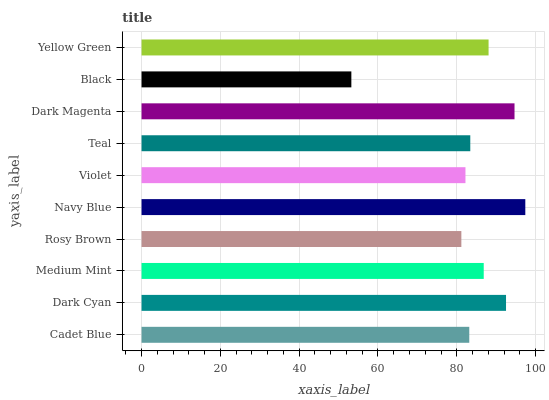Is Black the minimum?
Answer yes or no. Yes. Is Navy Blue the maximum?
Answer yes or no. Yes. Is Dark Cyan the minimum?
Answer yes or no. No. Is Dark Cyan the maximum?
Answer yes or no. No. Is Dark Cyan greater than Cadet Blue?
Answer yes or no. Yes. Is Cadet Blue less than Dark Cyan?
Answer yes or no. Yes. Is Cadet Blue greater than Dark Cyan?
Answer yes or no. No. Is Dark Cyan less than Cadet Blue?
Answer yes or no. No. Is Medium Mint the high median?
Answer yes or no. Yes. Is Teal the low median?
Answer yes or no. Yes. Is Dark Magenta the high median?
Answer yes or no. No. Is Yellow Green the low median?
Answer yes or no. No. 